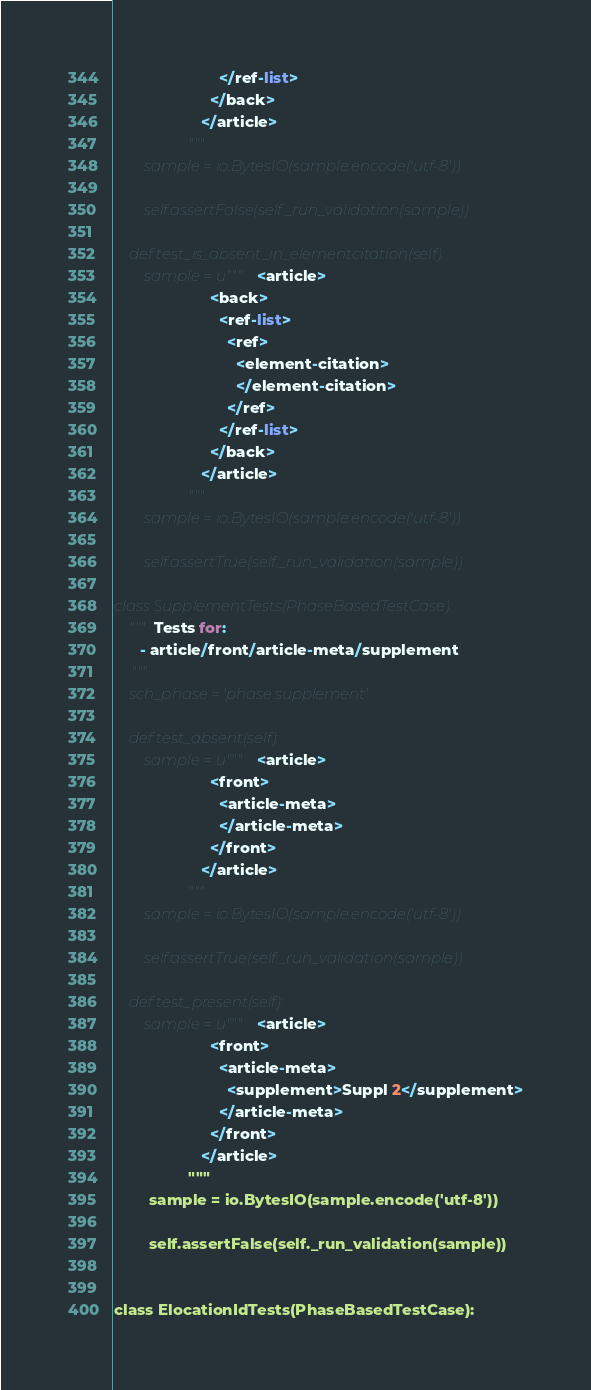<code> <loc_0><loc_0><loc_500><loc_500><_Python_>                        </ref-list>
                      </back>
                    </article>
                 """
        sample = io.BytesIO(sample.encode('utf-8'))

        self.assertFalse(self._run_validation(sample))

    def test_is_absent_in_elementcitation(self):
        sample = u"""<article>
                      <back>
                        <ref-list>
                          <ref>
                            <element-citation>
                            </element-citation>
                          </ref>
                        </ref-list>
                      </back>
                    </article>
                 """
        sample = io.BytesIO(sample.encode('utf-8'))

        self.assertTrue(self._run_validation(sample))

class SupplementTests(PhaseBasedTestCase):
    """Tests for:
      - article/front/article-meta/supplement
    """
    sch_phase = 'phase.supplement'

    def test_absent(self):
        sample = u"""<article>
                      <front>
                        <article-meta>
                        </article-meta>
                      </front>
                    </article>
                 """
        sample = io.BytesIO(sample.encode('utf-8'))

        self.assertTrue(self._run_validation(sample))

    def test_present(self):
        sample = u"""<article>
                      <front>
                        <article-meta>
                          <supplement>Suppl 2</supplement>
                        </article-meta>
                      </front>
                    </article>
                 """
        sample = io.BytesIO(sample.encode('utf-8'))

        self.assertFalse(self._run_validation(sample))


class ElocationIdTests(PhaseBasedTestCase):</code> 